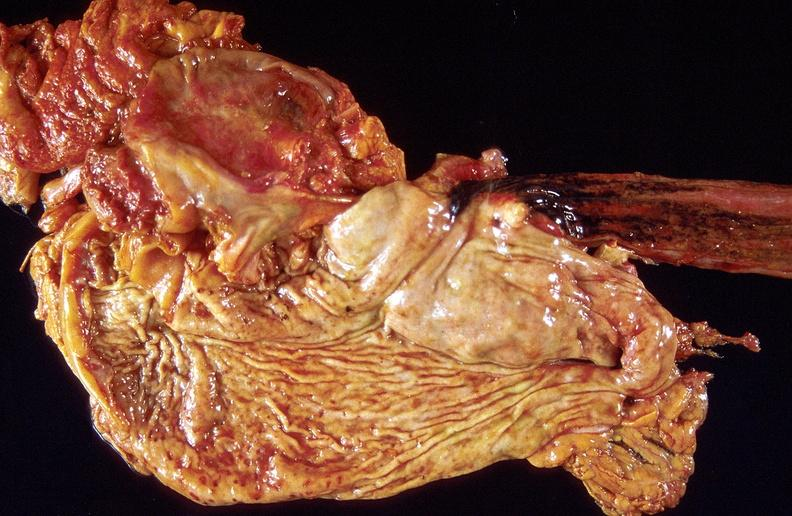does malignant lymphoma show stress ulcers, stomach?
Answer the question using a single word or phrase. No 